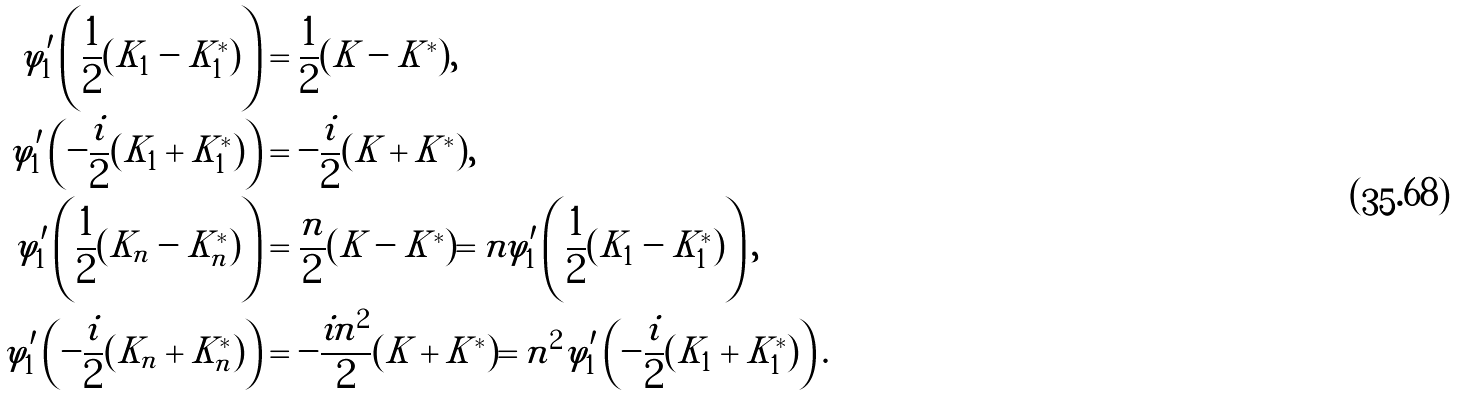Convert formula to latex. <formula><loc_0><loc_0><loc_500><loc_500>\varphi ^ { \prime } _ { 1 } \left ( \frac { 1 } { 2 } ( K _ { 1 } - K _ { 1 } ^ { * } ) \right ) & = \frac { 1 } { 2 } ( K - K ^ { * } ) , \\ \varphi ^ { \prime } _ { 1 } \left ( - \frac { i } { 2 } ( K _ { 1 } + K _ { 1 } ^ { * } ) \right ) & = - \frac { i } { 2 } ( K + K ^ { * } ) , \\ \varphi ^ { \prime } _ { 1 } \left ( \frac { 1 } { 2 } ( K _ { n } - K _ { n } ^ { * } ) \right ) & = \frac { n } { 2 } ( K - K ^ { * } ) = n \varphi ^ { \prime } _ { 1 } \left ( \frac { 1 } { 2 } ( K _ { 1 } - K _ { 1 } ^ { * } ) \right ) , \\ \varphi ^ { \prime } _ { 1 } \left ( - \frac { i } { 2 } ( K _ { n } + K _ { n } ^ { * } ) \right ) & = - \frac { i n ^ { 2 } } { 2 } ( K + K ^ { * } ) = n ^ { 2 } \varphi ^ { \prime } _ { 1 } \left ( - \frac { i } { 2 } ( K _ { 1 } + K _ { 1 } ^ { * } ) \right ) .</formula> 